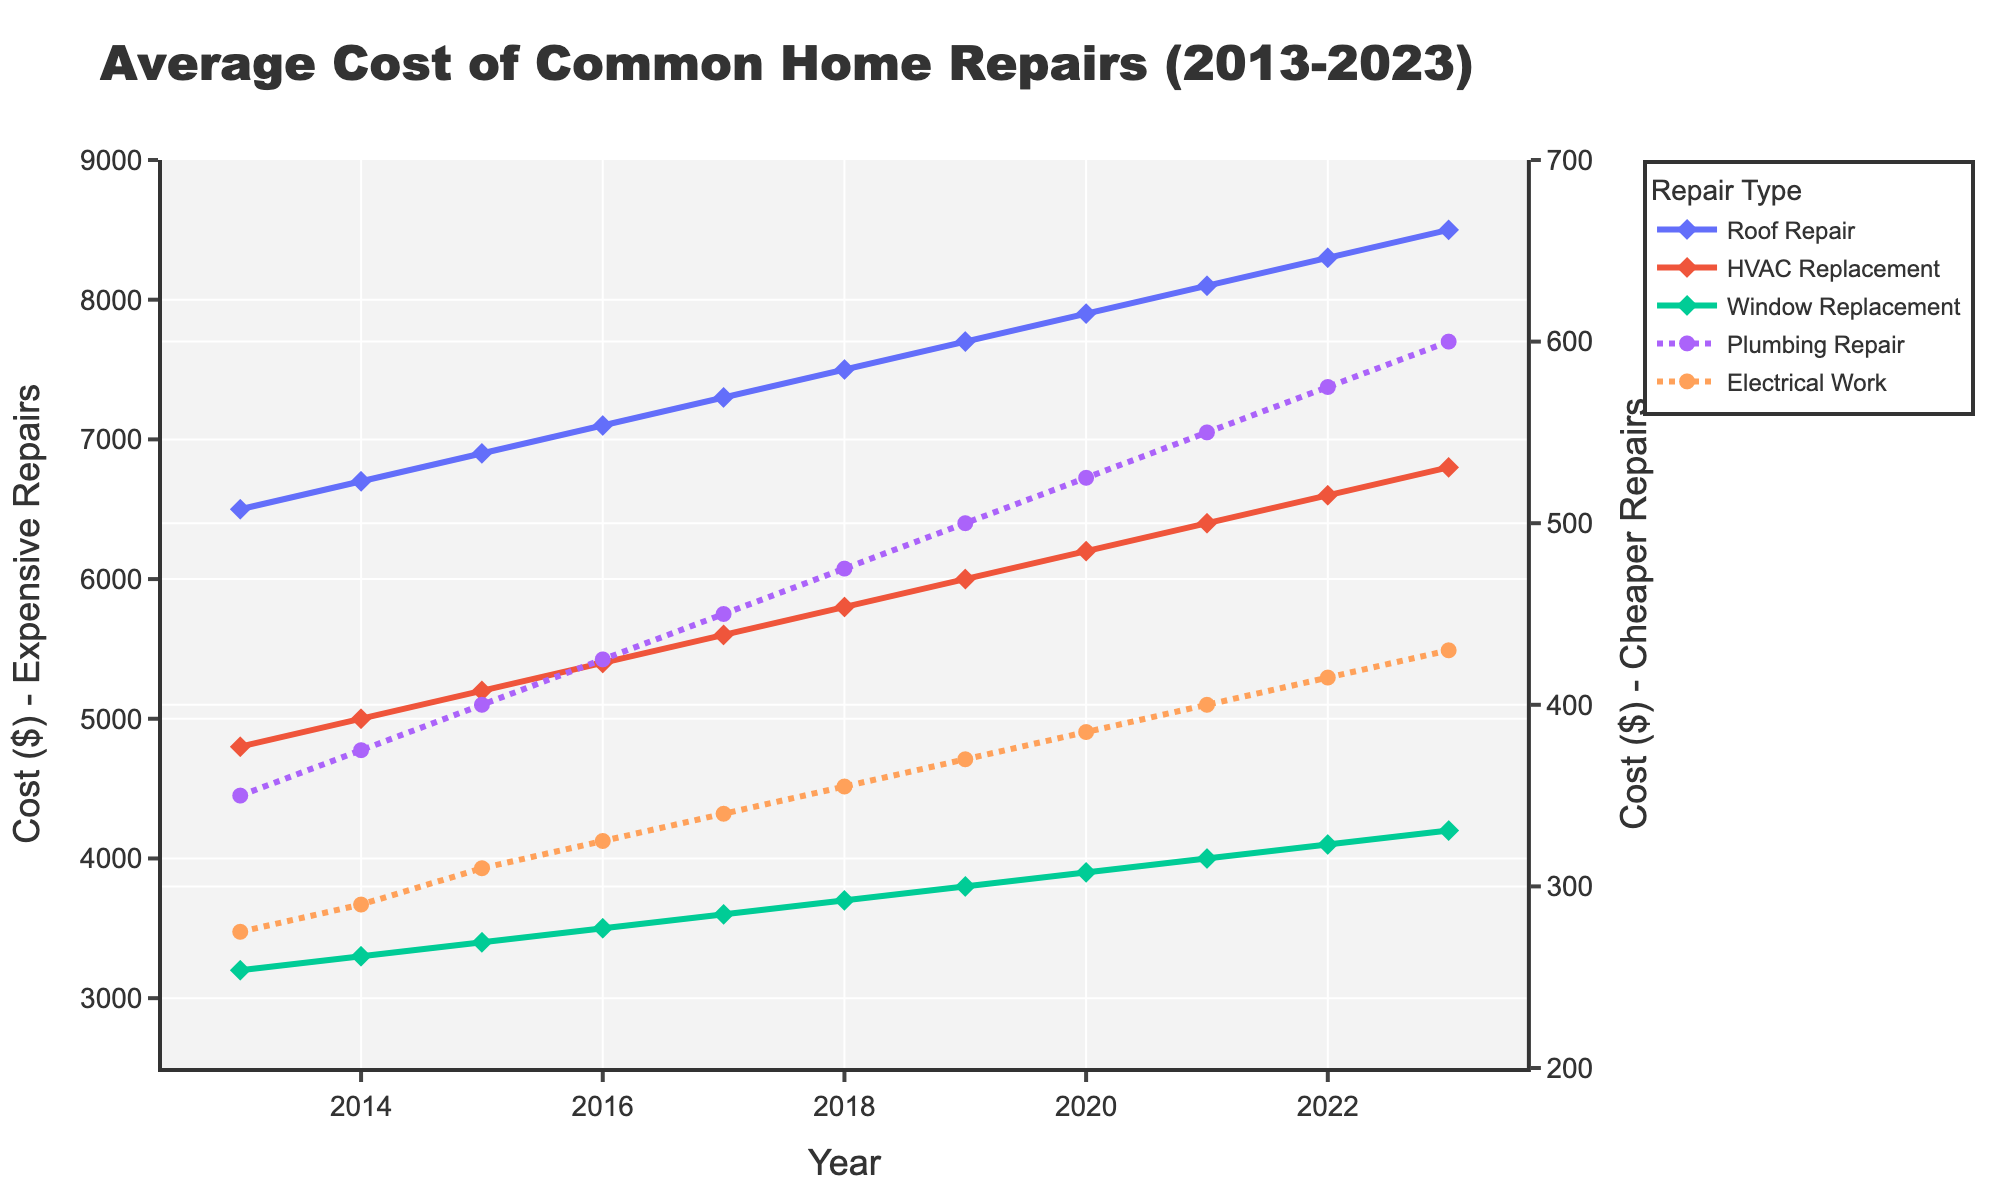what was the cost of roof repairs in 2017? The figure indicates that each year is marked along the x-axis and the corresponding values for different repair costs are plotted as lines. The chart label for “Roof Repair” in 2017 sits at $7300.
Answer: $7300 During which year did HVAC replacements exceed $6000? To address this, we scan the HVAC Replacement line and observe the plotted points where the value surpasses $6000. This happens starting from 2019.
Answer: 2019 What is the total cost of window replacements from 2013 to 2023? Summing up the yearly costs of window replacements: 3200 (2013) + 3300 (2014) + 3400 (2015) + 3500 (2016) + 3600 (2017) + 3700 (2018) + 3800 (2019) + 3900 (2020) + 4000 (2021) + 4100 (2022) + 4200 (2023) gives $41700.
Answer: $41700 Which repair had the lowest cost in 2023 and what was it? Examining the endpoint of all lines in the figure for the year 2023, "Electrical Work" is the line with the lowest endpoint, positioned at $430.
Answer: Electrical Work, $430 What was the difference in cost between Plumbing Repair and Electrical Work in 2023? First, we look at the 2023 values for Plumbing Repair ($600) and Electrical Work($430). Their difference is calculated as $600 - $430.
Answer: $170 How did the cost of Roof Repair change from 2015 to 2020? From the figure, the cost for Roof Repair in 2015 was $6900 and in 2020, it was $7900. The difference is calculated as $7900 - $6900.
Answer: $1000 Which repair type saw the steepest increase over the 10-year period? On visual inspection of the slopes of each line plotted, "Roof Repair" exhibits the steepest overall increase from $6500 in 2013 to $8500 in 2023, demonstrating the sharpest incline.
Answer: Roof Repair Did the cost of Electrical Work ever exceed the cost of Plumbing Repair between 2013 to 2023? By comparing the lines for Electrical Work and Plumbing Repair over time, Electrical Work consistently stays below the cost of Plumbing Repair throughout the 10-year period.
Answer: No What’s the average cost of HVAC Replacement from 2013 to 2023? Summing up the yearly costs of HVAC Replacement: 4800, 5000, 5200, 5400, 5600, 5800, 6000, 6200, 6400, 6600, 6800, which totals to $62400 and dividing by 11 years gives an average of $62400/11.
Answer: $5672.73 